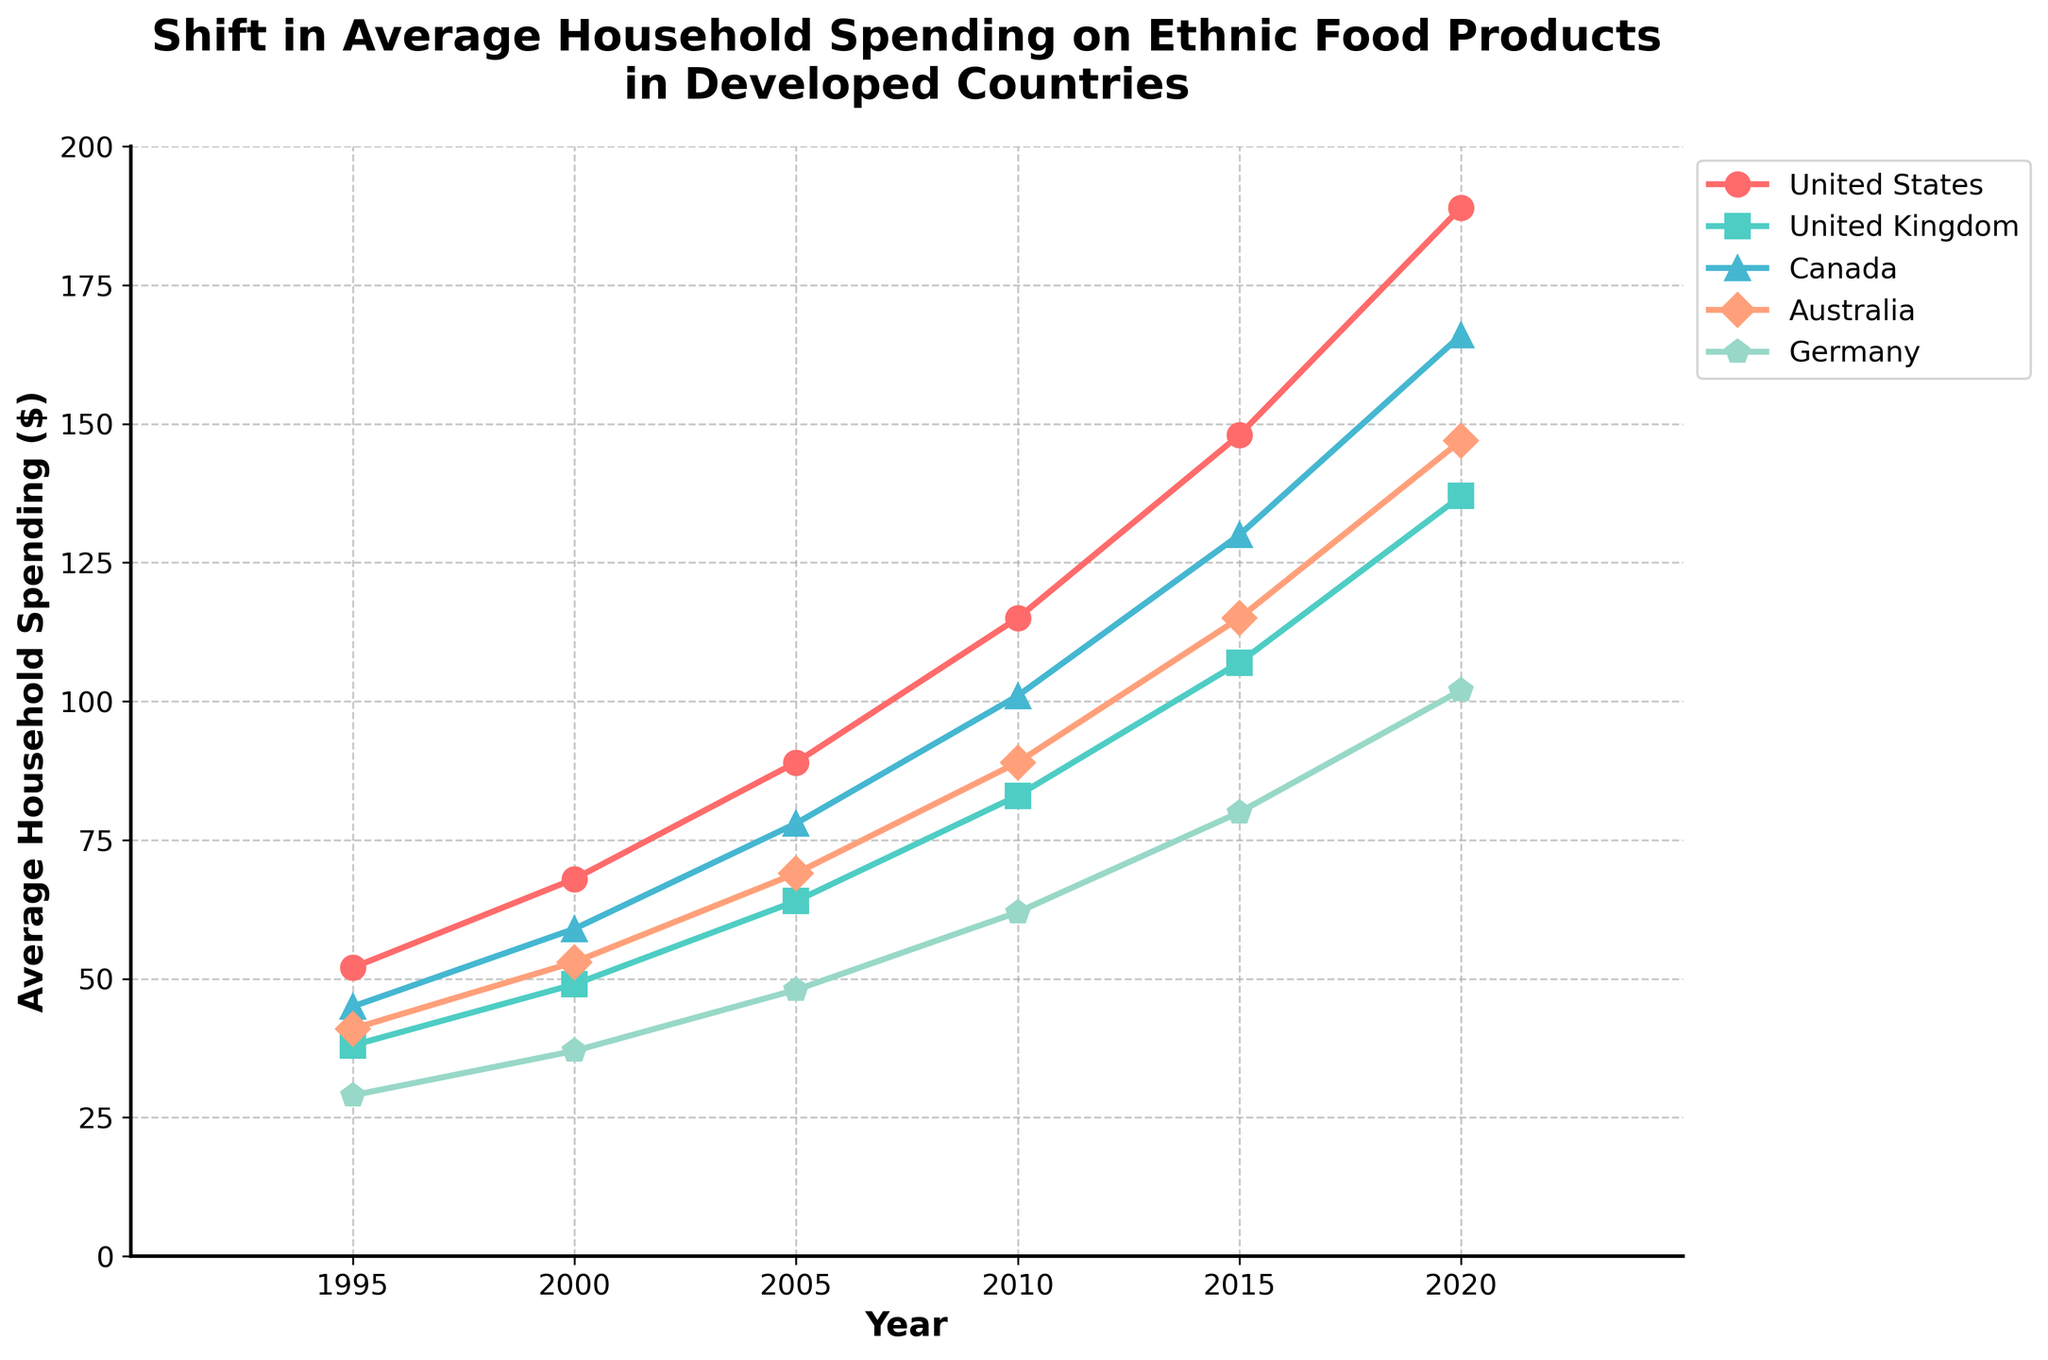What is the average household spending on ethnic food products in the United States in 1995 and 2020? To find this, refer to the plot and look at the spending on the line representing the United States in 1995, which is $52, and in 2020, which is $189.
Answer: $52, $189 Which country showed the highest increase in household spending on ethnic food products from 1995 to 2020? We need to look at the chart and find the difference between the spending in 2020 and 1995 for each country. The United States (189 - 52 = 137), United Kingdom (137 - 38 = 99), Canada (166 - 45 = 121), Australia (147 - 41 = 106), and Germany (102 - 29 = 73). The United States shows the highest increase of $137.
Answer: United States By how much did household spending on ethnic food products in Germany increase from 2000 to 2015? Find the spending for Germany in 2000 and 2015. In 2000 it was $37, and in 2015 it was $80. The increase is calculated as $80 - $37 = $43.
Answer: $43 Which countries had higher household spending on ethnic food products than Germany in 2010? We need to compare the values from the year 2010. Germany had $62. United States ($115), United Kingdom ($83), Canada ($101), and Australia ($89). All four countries had higher spending than Germany.
Answer: United States, United Kingdom, Canada, Australia What is the combined household spending on ethnic food products in Australia and Canada in 2015? Find the spending in 2015 for Australia ($115) and Canada ($130). Combine them by summing, $115 + $130 = $245.
Answer: $245 Which country had the lowest household spending on ethnic food products in 1995? Look at the values in 1995 for each country: United States ($52), United Kingdom ($38), Canada ($45), Australia ($41), Germany ($29). The lowest spending is $29 in Germany.
Answer: Germany What is the percentage increase in household spending on ethnic food products in the United Kingdom from 1995 to 2020? First, find the initial and final values: 1995 ($38) and 2020 ($137). Calculate the difference ($137 - $38 = $99), then the percentage increase ($99 / $38 * 100 = 260.53%).
Answer: 260.53% Compare the household spending on ethnic food products in Canada and the United Kingdom in 2005 and indicate which country spent more. Refer to the values for 2005: Canada ($78) and United Kingdom ($64). Canada spent more than the United Kingdom.
Answer: Canada By how much did household spending on ethnic food products in Australia increase from 2005 to 2020? Find the values for Australia in 2005 ($69) and 2020 ($147). Calculate the difference: $147 - $69 = $78.
Answer: $78 What trend do you observe for the household spending on ethnic food products in all the countries over the years? Observing the plot shows a general upward trend in household spending from 1995 to 2020 across all countries.
Answer: Upward trend 